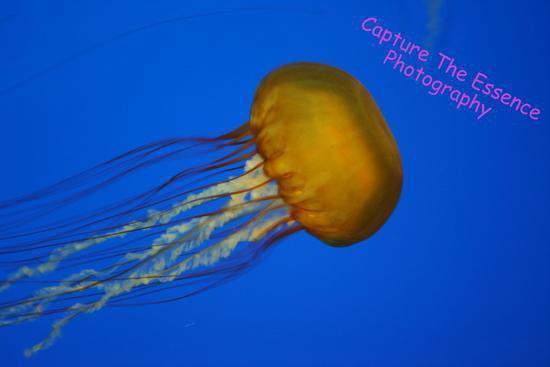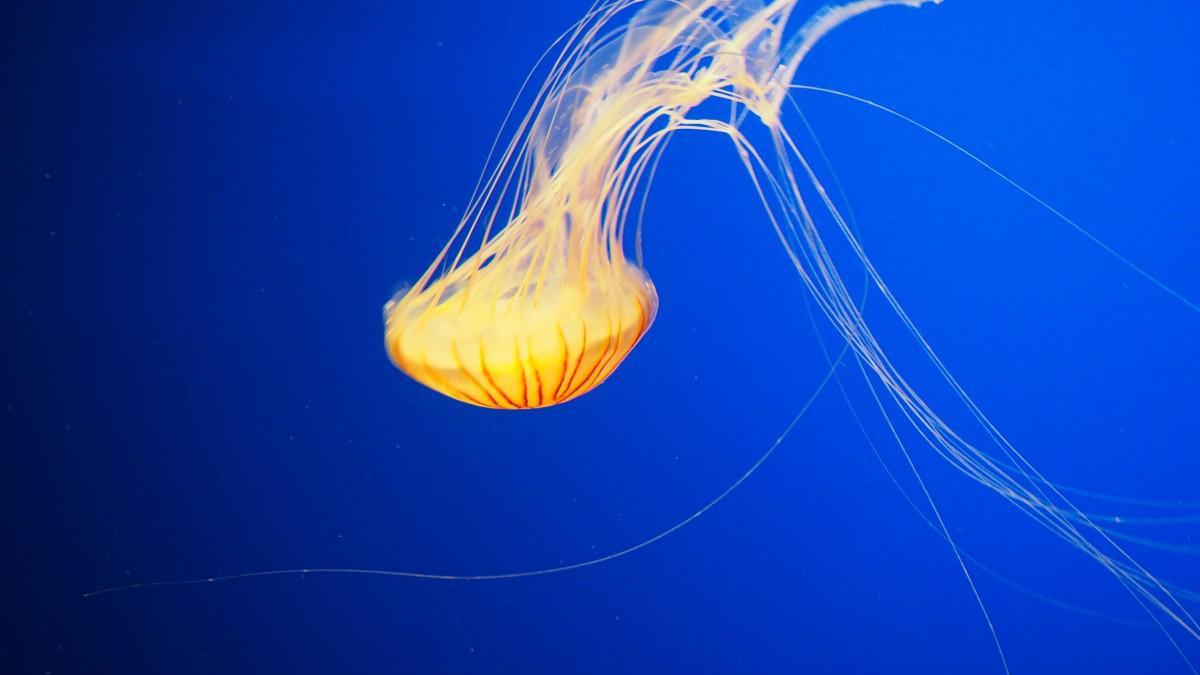The first image is the image on the left, the second image is the image on the right. Considering the images on both sides, is "The right-hand jellyfish appears tilted down, with its """"cap"""" going  rightward." valid? Answer yes or no. No. 